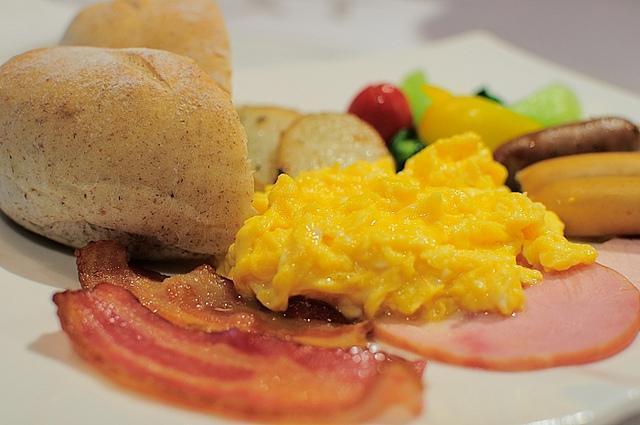How many kinds of meat are there?
Give a very brief answer. 3. How many people have been partially caught by the camera?
Give a very brief answer. 0. 